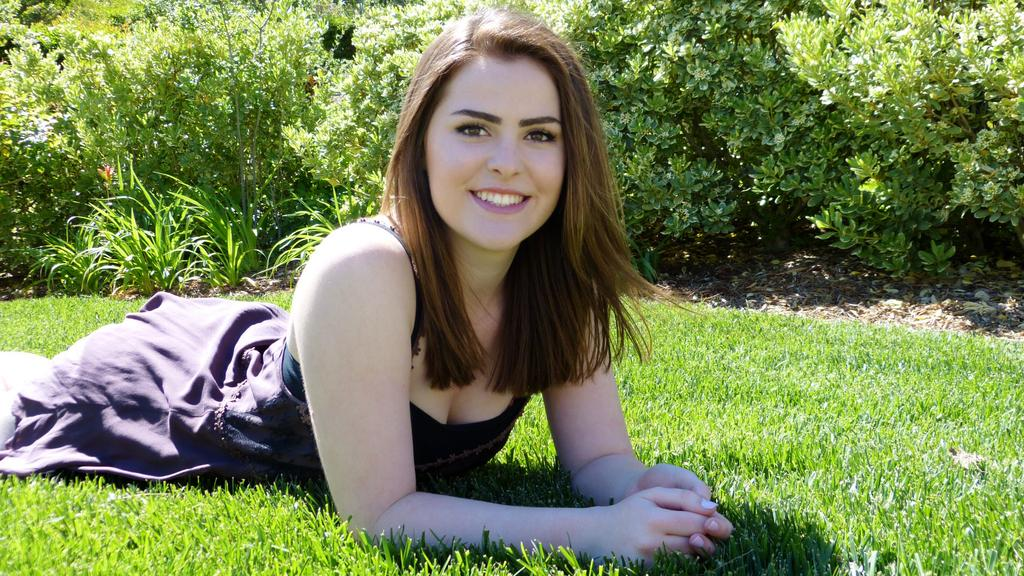Who is present in the image? There is a woman in the image. What is the woman doing in the image? The woman is lying on the grass. What can be seen in the background of the image? There are bushes at the top of the image. How many books are stacked on the linen in the image? There are no books or linen present in the image; it features a woman lying on the grass with bushes in the background. 